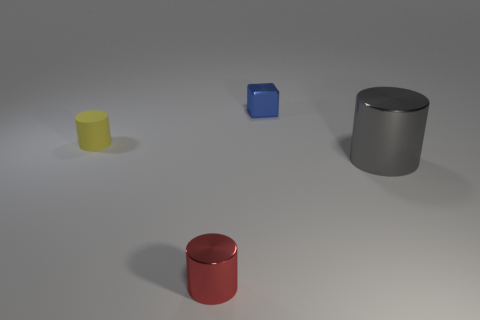Add 2 big shiny objects. How many objects exist? 6 Subtract all yellow matte cylinders. How many cylinders are left? 2 Subtract all gray cylinders. How many cylinders are left? 2 Subtract all green spheres. How many gray cylinders are left? 1 Subtract 0 cyan cylinders. How many objects are left? 4 Subtract all cylinders. How many objects are left? 1 Subtract 1 cubes. How many cubes are left? 0 Subtract all gray cubes. Subtract all yellow balls. How many cubes are left? 1 Subtract all small purple metallic blocks. Subtract all shiny cylinders. How many objects are left? 2 Add 2 large gray cylinders. How many large gray cylinders are left? 3 